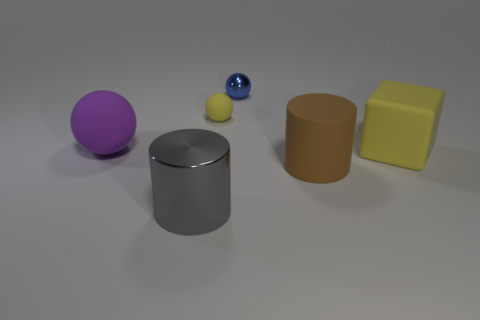Is the small yellow sphere made of the same material as the yellow object in front of the large purple sphere?
Make the answer very short. Yes. What number of green things are either matte cylinders or tiny matte spheres?
Keep it short and to the point. 0. The yellow block that is the same material as the large purple ball is what size?
Provide a short and direct response. Large. What number of big yellow matte objects have the same shape as the big gray metal object?
Your answer should be compact. 0. Are there more small blue shiny spheres in front of the large yellow cube than big purple balls that are on the left side of the metallic ball?
Offer a very short reply. No. There is a large block; is it the same color as the sphere that is behind the small yellow matte sphere?
Your response must be concise. No. There is a yellow thing that is the same size as the shiny ball; what is it made of?
Provide a succinct answer. Rubber. How many things are either large matte cylinders or big cylinders that are behind the big metallic object?
Provide a succinct answer. 1. Does the gray metallic cylinder have the same size as the matte thing to the right of the rubber cylinder?
Keep it short and to the point. Yes. How many cylinders are big gray things or brown matte objects?
Your answer should be very brief. 2. 